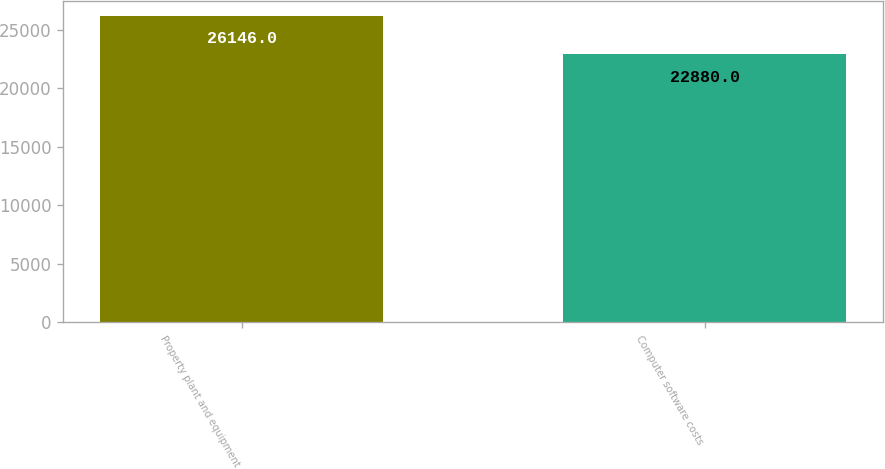Convert chart. <chart><loc_0><loc_0><loc_500><loc_500><bar_chart><fcel>Property plant and equipment<fcel>Computer software costs<nl><fcel>26146<fcel>22880<nl></chart> 